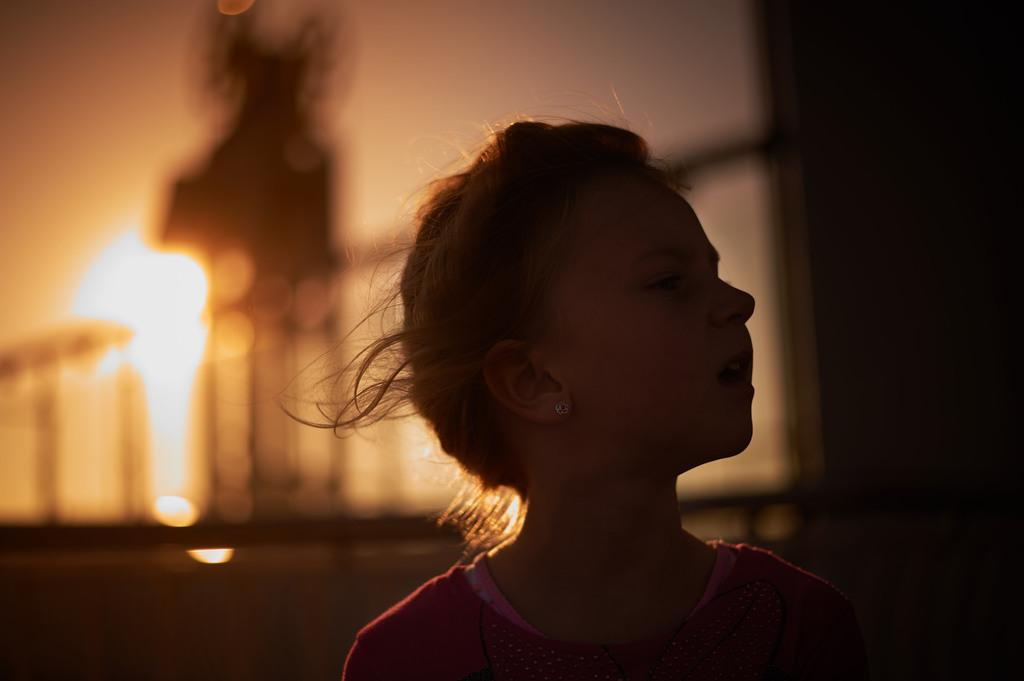Who is the main subject in the foreground of the image? There is a girl in the foreground of the image. What can be seen in the background of the image? There is a railing in the background of the image. What is the source of light in the image? The fire in the image provides the source of light. What is visible at the top of the image? The sky is visible at the top of the image. What type of flag is being waved by the committee in the image? There is no committee or flag present in the image. 